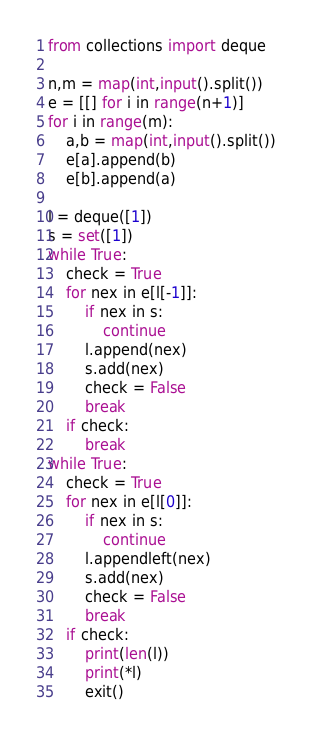Convert code to text. <code><loc_0><loc_0><loc_500><loc_500><_Python_>from collections import deque

n,m = map(int,input().split())
e = [[] for i in range(n+1)]
for i in range(m):
    a,b = map(int,input().split())
    e[a].append(b)
    e[b].append(a)

l = deque([1])
s = set([1])
while True:
    check = True
    for nex in e[l[-1]]:
        if nex in s:
            continue
        l.append(nex)
        s.add(nex)
        check = False
        break
    if check:
        break
while True:
    check = True
    for nex in e[l[0]]:
        if nex in s:
            continue
        l.appendleft(nex)
        s.add(nex)
        check = False
        break
    if check:
        print(len(l))
        print(*l)
        exit()</code> 